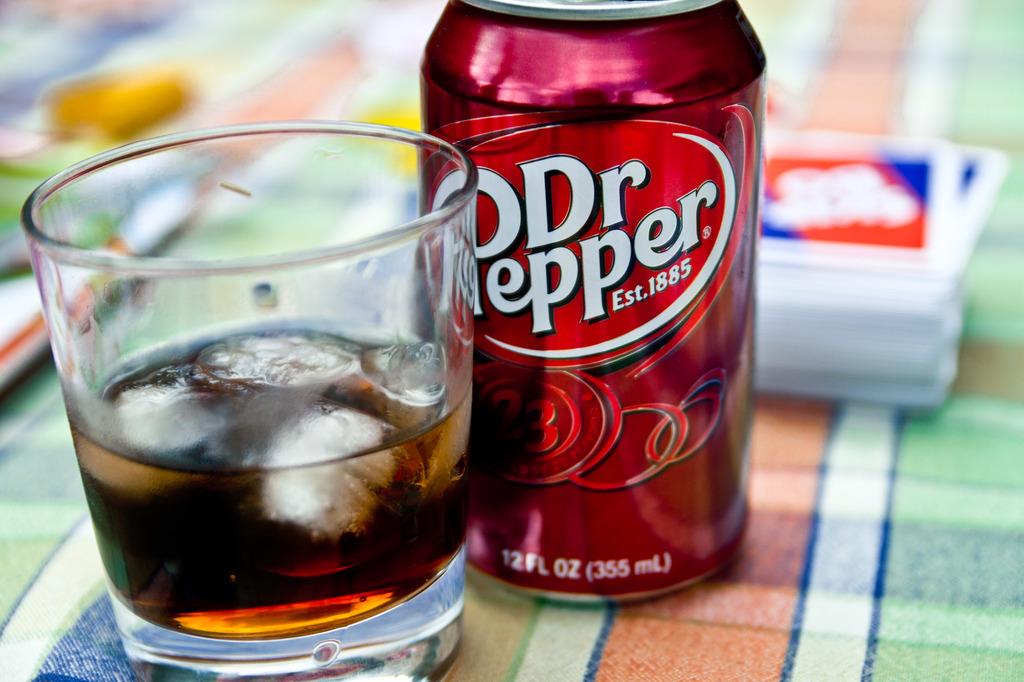When was dr. pepper established?
Give a very brief answer. 1885. 